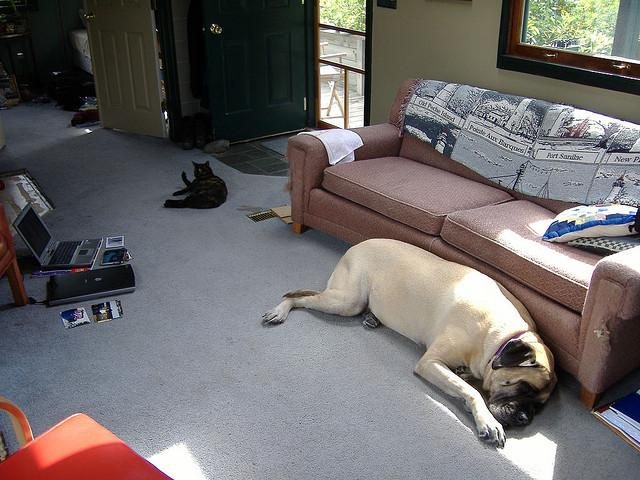Where is the person most likely working in the living room while the pets lounge? Please explain your reasoning. floor. The person has the laptop on the floor. 